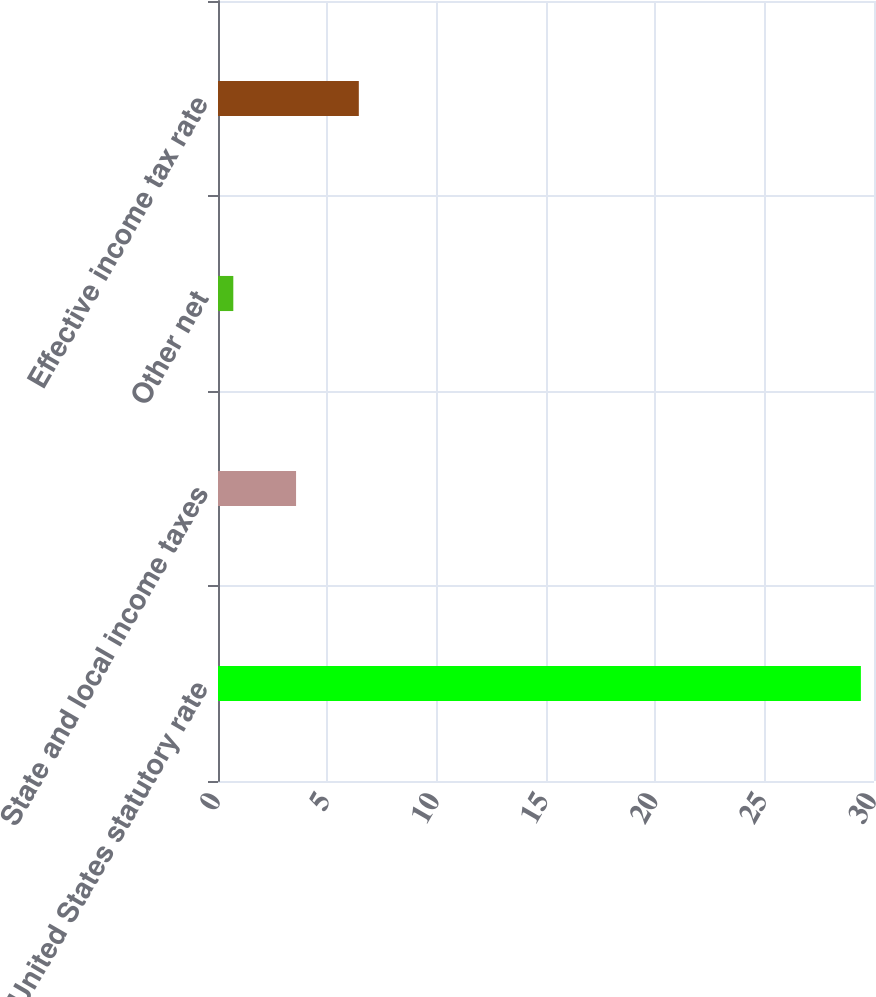Convert chart. <chart><loc_0><loc_0><loc_500><loc_500><bar_chart><fcel>United States statutory rate<fcel>State and local income taxes<fcel>Other net<fcel>Effective income tax rate<nl><fcel>29.4<fcel>3.57<fcel>0.7<fcel>6.44<nl></chart> 